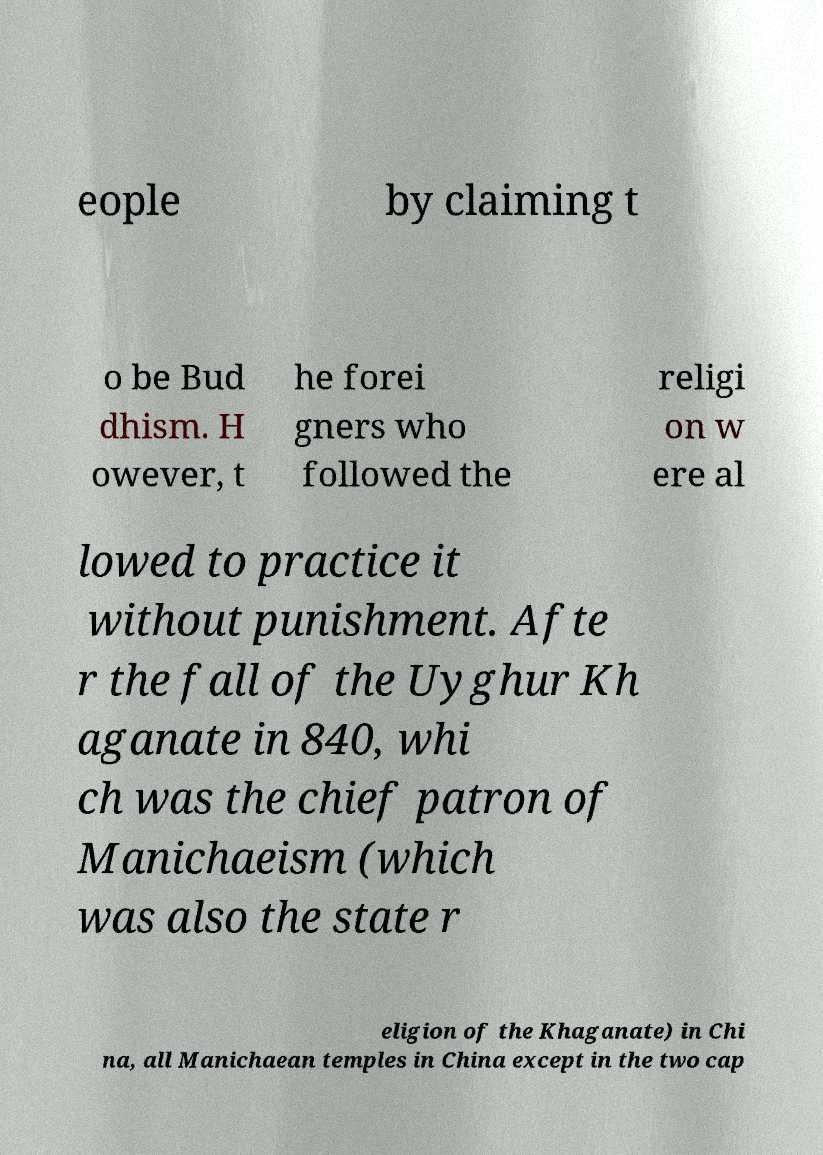Could you extract and type out the text from this image? eople by claiming t o be Bud dhism. H owever, t he forei gners who followed the religi on w ere al lowed to practice it without punishment. Afte r the fall of the Uyghur Kh aganate in 840, whi ch was the chief patron of Manichaeism (which was also the state r eligion of the Khaganate) in Chi na, all Manichaean temples in China except in the two cap 